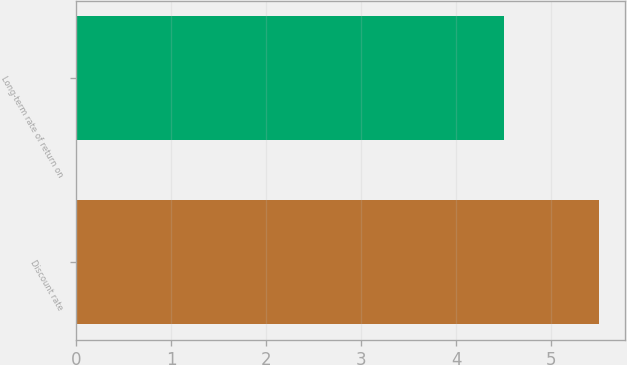Convert chart to OTSL. <chart><loc_0><loc_0><loc_500><loc_500><bar_chart><fcel>Discount rate<fcel>Long-term rate of return on<nl><fcel>5.5<fcel>4.5<nl></chart> 